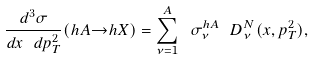Convert formula to latex. <formula><loc_0><loc_0><loc_500><loc_500>\frac { d ^ { 3 } \sigma } { d x \ d p ^ { 2 } _ { T } } ( h A { \rightarrow } h X ) = \sum _ { \nu = 1 } ^ { A } \ \sigma ^ { h A } _ { \nu } \ D ^ { N } _ { \nu } ( x , p ^ { 2 } _ { T } ) ,</formula> 